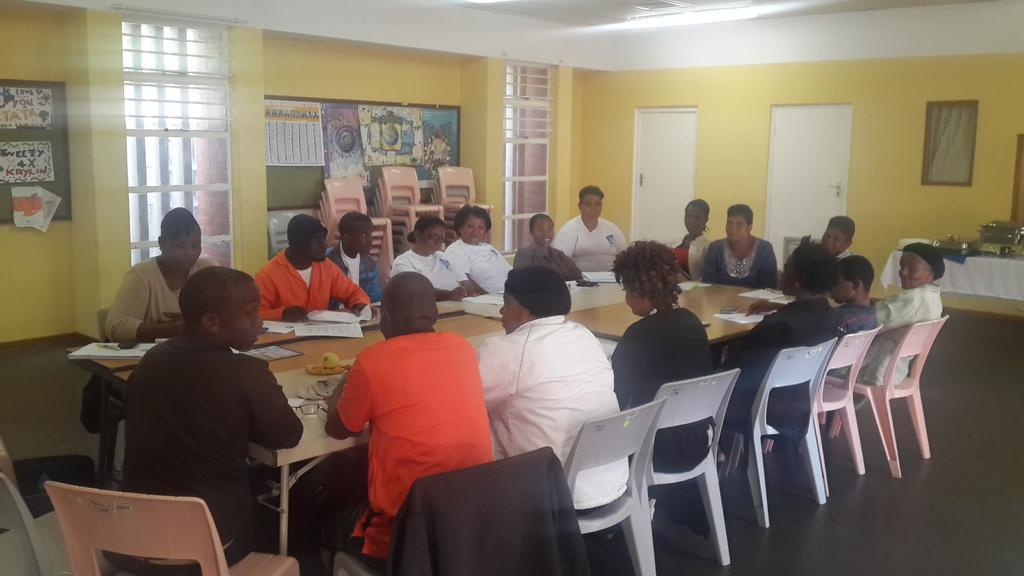Can you describe this image briefly? There is a group of people sitting on a chair and they are discussing about something important. In the background we can see a bunch of chairs and these are doors. 